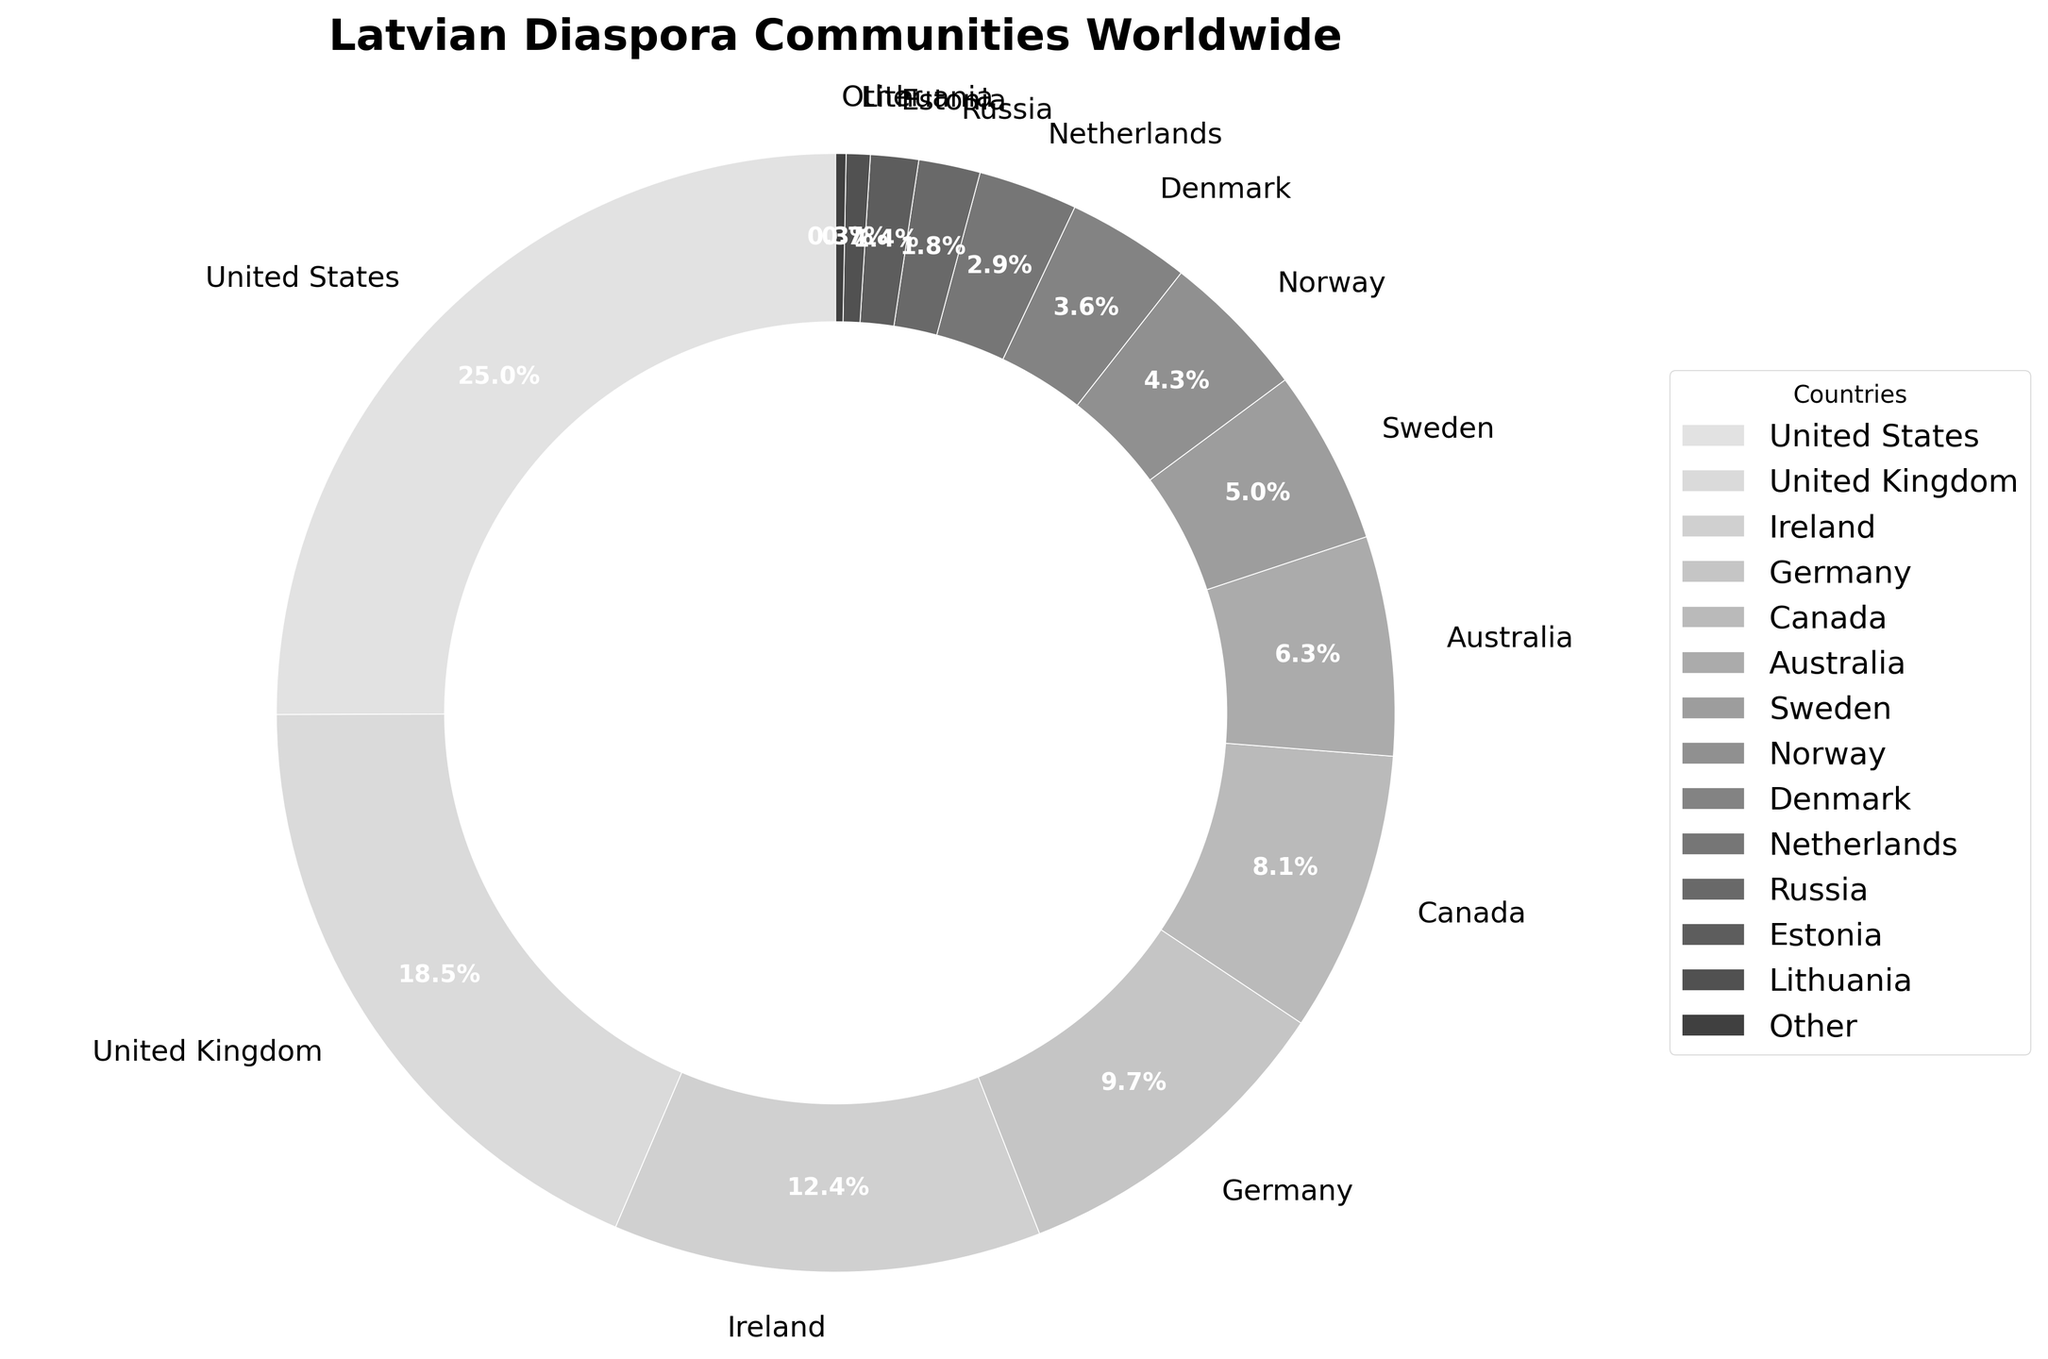What percentage of the Latvian diaspora resides in the United States? Refer to the chart and locate the segment labeled "United States." The percentage is directly given in this label.
Answer: 25.3% Which country has the second largest percentage of the Latvian diaspora? Look for the segment with the second largest size after the United States. This segment is labeled "United Kingdom."
Answer: United Kingdom How much greater is the percentage of Latvian diaspora in Ireland compared to Canada? Identify the segments labeled "Ireland" and "Canada." Note their percentages: 12.5% for Ireland and 8.2% for Canada. Subtract the smaller percentage from the larger one: 12.5% - 8.2% = 4.3%.
Answer: 4.3% What is the combined percentage of Latvian diaspora communities in the top three countries? Identify the top three segments: United States (25.3%), United Kingdom (18.7%), and Ireland (12.5%). Add these percentages together: 25.3% + 18.7% + 12.5% = 56.5%.
Answer: 56.5% How many countries have a percentage of the Latvian diaspora that is less than 5%? Identify all segments with percentages less than 5%. These are Sweden (5.1%), Norway (4.3%), Denmark (3.6%), Netherlands (2.9%), Russia (1.8%), Estonia (1.4%), Lithuania (0.7%), and Other (0.3%). Count these segments which add up to 8.
Answer: 8 Which countries have a larger percentage of the Latvian diaspora than Germany? Identify the segment for Germany (9.8%) and find the segments with a higher percentage. These are United States (25.3%), United Kingdom (18.7%), and Ireland (12.5%).
Answer: United States, United Kingdom, Ireland What is the average percentage of Latvian diaspora in the Scandinavian countries listed (Sweden, Norway, Denmark)? Identify the segments for Sweden (5.1%), Norway (4.3%), and Denmark (3.6%). Sum these percentages and divide by the number of countries: (5.1% + 4.3% + 3.6%) / 3 = 4.33%.
Answer: 4.33% What is the total percentage of the Latvian diaspora in countries with less than 3%? Identify the segments with percentages less than 3%: Netherlands (2.9%), Russia (1.8%), Estonia (1.4%), Lithuania (0.7%), and Other (0.3%). Sum these percentages: 2.9% + 1.8% + 1.4% + 0.7% + 0.3% = 7.1%.
Answer: 7.1% Which country has a smaller percentage of the Latvian diaspora, Australia or Canada? Identify the segments for Australia (6.4%) and Canada (8.2%). Compare their percentages.
Answer: Australia 